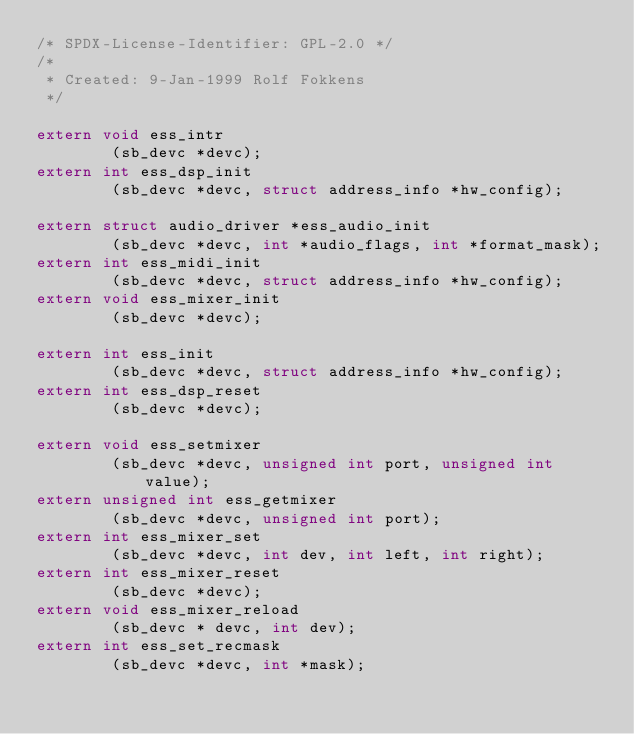Convert code to text. <code><loc_0><loc_0><loc_500><loc_500><_C_>/* SPDX-License-Identifier: GPL-2.0 */
/*
 * Created: 9-Jan-1999 Rolf Fokkens
 */

extern void ess_intr
		(sb_devc *devc);
extern int ess_dsp_init
		(sb_devc *devc, struct address_info *hw_config);

extern struct audio_driver *ess_audio_init
		(sb_devc *devc, int *audio_flags, int *format_mask);
extern int ess_midi_init
		(sb_devc *devc, struct address_info *hw_config);
extern void ess_mixer_init
		(sb_devc *devc);

extern int ess_init
		(sb_devc *devc, struct address_info *hw_config);
extern int ess_dsp_reset
		(sb_devc *devc);

extern void ess_setmixer
		(sb_devc *devc, unsigned int port, unsigned int value);
extern unsigned int ess_getmixer
		(sb_devc *devc, unsigned int port);
extern int ess_mixer_set
		(sb_devc *devc, int dev, int left, int right);
extern int ess_mixer_reset
		(sb_devc *devc);
extern void ess_mixer_reload
		(sb_devc * devc, int dev);
extern int ess_set_recmask
		(sb_devc *devc, int *mask);

</code> 